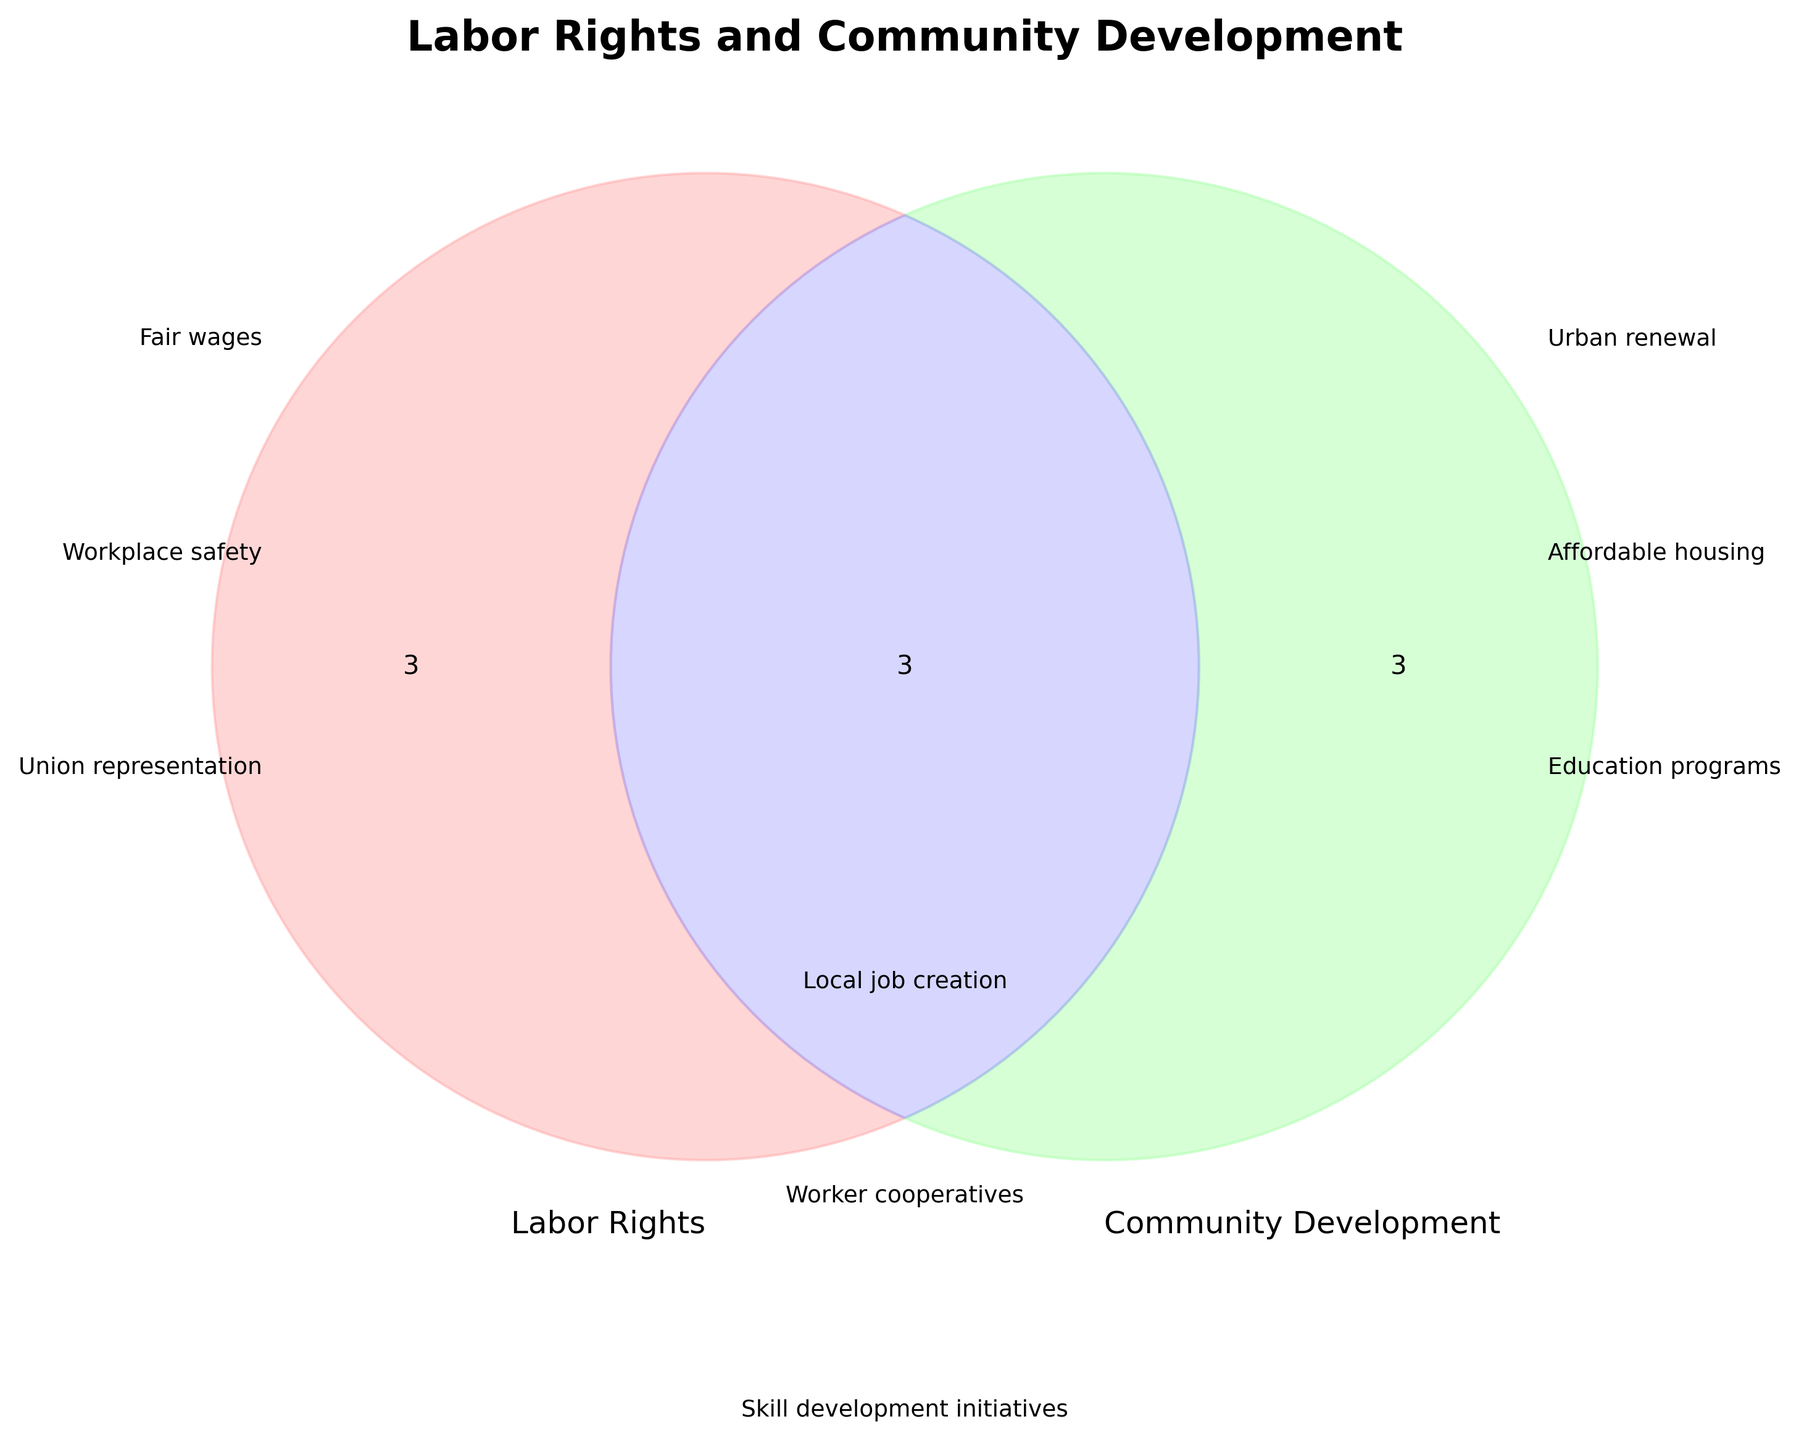How many themes are listed under the "Labor Rights" category? The "Labor Rights" category lists three themes: Fair wages, Workplace safety, and Union representation.
Answer: Three What is the color used to represent the "Labor Rights" circle? The "Labor Rights" circle is represented by the color red.
Answer: Red Identify one theme that is common between "Labor Rights" and "Community Development". A theme listed under the intersection category that appears in both "Labor Rights" and "Community Development" is Local job creation.
Answer: Local job creation What are the themes mentioned in the intersection of both circles? The themes in the intersection of both "Labor Rights" and "Community Development" groups are Local job creation, Worker cooperatives, and Skill development initiatives.
Answer: Local job creation, Worker cooperatives, Skill development initiatives Which category features "Affordable housing"? "Affordable housing" is listed under the "Community Development" category.
Answer: Community Development State the title of the Venn Diagram. The title of the Venn Diagram is "Labor Rights and Community Development".
Answer: Labor Rights and Community Development What are the colors representing "Community Development" and the intersection areas? "Community Development" is represented by the color green, while the intersection area is represented by the color blue.
Answer: Green and Blue How many themes are listed uniquely under "Community Development"? There are three themes listed uniquely under "Community Development": Urban renewal, Affordable housing, and Education programs.
Answer: Three Compare the number of themes exclusively listed under "Labor Rights" and those exclusively under "Community Development". Which has more? Both "Labor Rights" and "Community Development" have an equal number of themes listed exclusively, which is three each.
Answer: Equal Identify an initiative that involves both labor and community elements but is not already commonly recognized (i.e., not in the intersection). An initiative that involves both elements could be Collective bargaining for improving Infrastructure development, which isn’t listed in the present Venn diagram but aligns with the two core principles.
Answer: Collective bargaining for improving Infrastructure development 